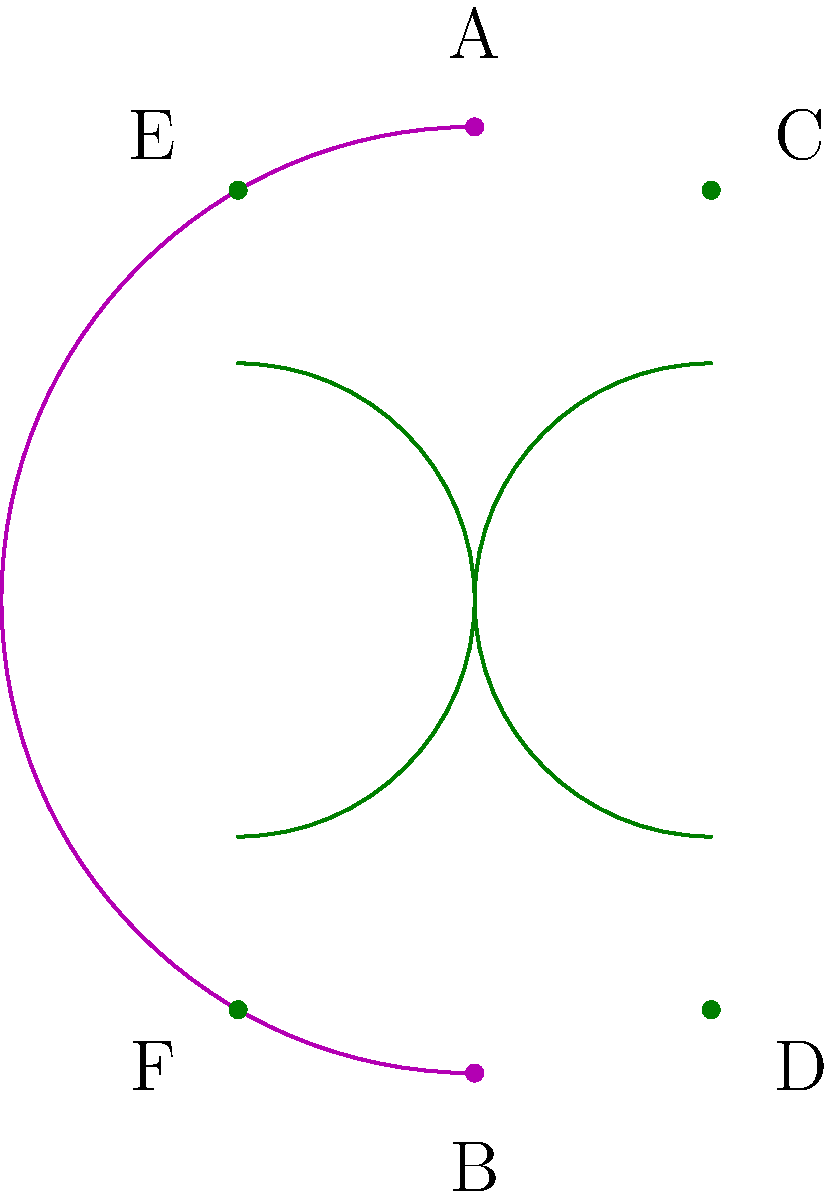In the Poincaré disk model of hyperbolic geometry shown above, which represents a costume design layout, lines AB, CD, and EF are geodesics (straight lines in hyperbolic space). If we consider these lines as seams in a costume, how would you describe their relationship to each other in hyperbolic space, and how might this influence your design choices? To understand the relationship between these lines in hyperbolic space and how it might influence costume design, let's break it down step-by-step:

1. In the Poincaré disk model, straight lines (geodesics) in hyperbolic space are represented by either:
   a) Diameters of the disk
   b) Circular arcs that intersect the boundary circle at right angles

2. Line AB is a diameter of the disk, representing a straight line through the center of the hyperbolic plane.

3. Lines CD and EF are circular arcs meeting the boundary at right angles, also representing straight lines in hyperbolic space.

4. In Euclidean geometry, we would say that CD and EF are parallel to AB. However, in hyperbolic geometry, these lines are called "ultraparallel."

5. Ultraparallel lines in hyperbolic space have the following properties:
   a) They never intersect, even when extended infinitely.
   b) They diverge from each other in both directions.
   c) The distance between them increases as you move away from the point of closest approach.

6. In terms of costume design, this hyperbolic geometry could influence choices in the following ways:
   a) The diverging nature of the lines could be used to create an illusion of expansion or flow in the costume.
   b) The increasing distance between ultraparallel lines could be utilized to add volume or dramatic flair to certain parts of the garment.
   c) The curved appearance of straight lines (except for diameters) could inspire unique seam placements or decorative elements that follow these geodesics.
   d) The symmetry of the model could be incorporated into balanced design elements on both sides of the costume.

7. The non-Euclidean nature of this space means that angles and distances behave differently than in flat space, which could lead to innovative cutting and draping techniques that create unexpected visual effects when the costume is worn.
Answer: Ultraparallel, diverging, inspiring curved seams and expanding volumes in costume design. 